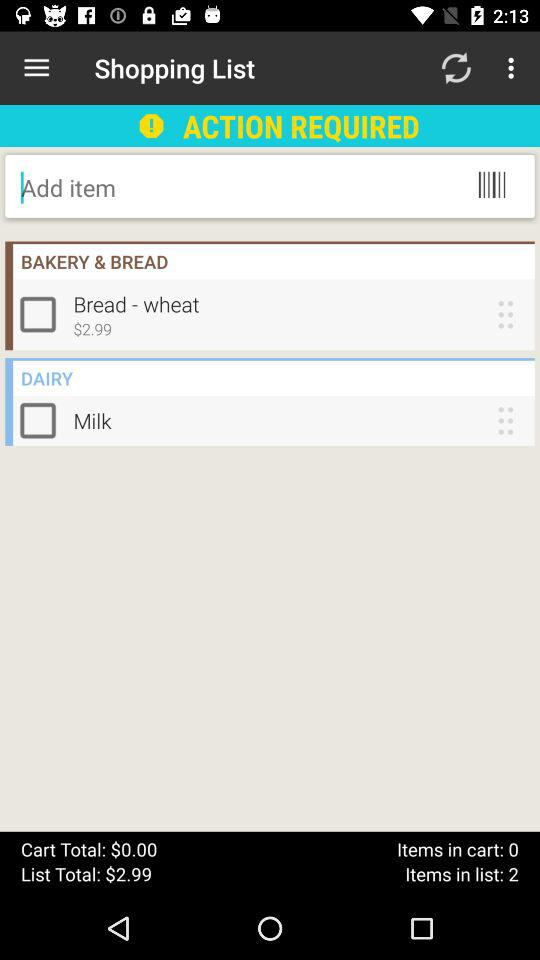How many items are there on the list? There are 2 items on the list. 